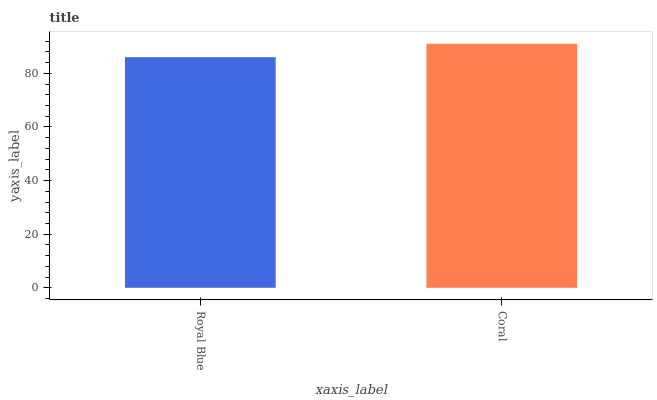Is Royal Blue the minimum?
Answer yes or no. Yes. Is Coral the maximum?
Answer yes or no. Yes. Is Coral the minimum?
Answer yes or no. No. Is Coral greater than Royal Blue?
Answer yes or no. Yes. Is Royal Blue less than Coral?
Answer yes or no. Yes. Is Royal Blue greater than Coral?
Answer yes or no. No. Is Coral less than Royal Blue?
Answer yes or no. No. Is Coral the high median?
Answer yes or no. Yes. Is Royal Blue the low median?
Answer yes or no. Yes. Is Royal Blue the high median?
Answer yes or no. No. Is Coral the low median?
Answer yes or no. No. 